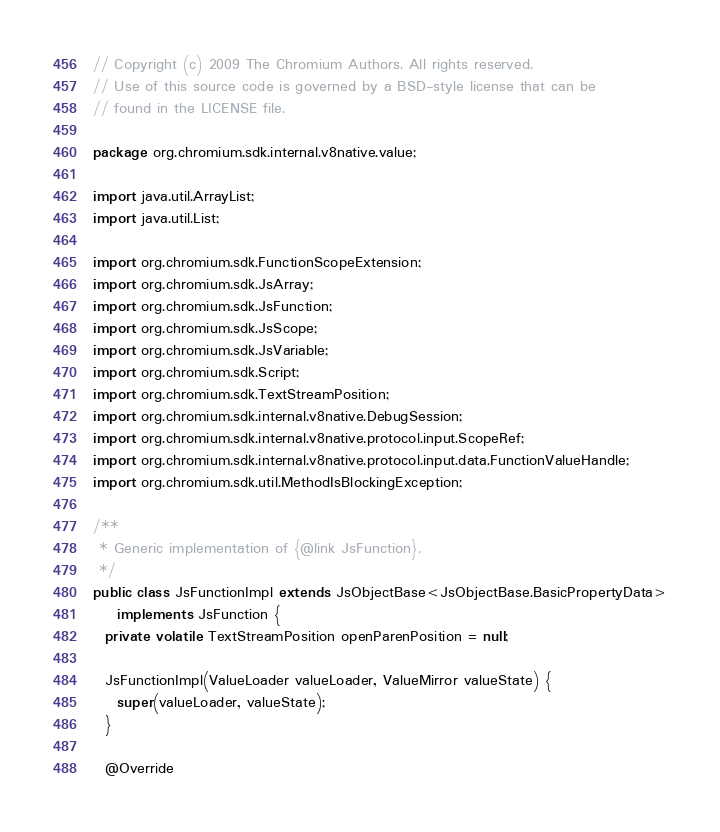Convert code to text. <code><loc_0><loc_0><loc_500><loc_500><_Java_>// Copyright (c) 2009 The Chromium Authors. All rights reserved.
// Use of this source code is governed by a BSD-style license that can be
// found in the LICENSE file.

package org.chromium.sdk.internal.v8native.value;

import java.util.ArrayList;
import java.util.List;

import org.chromium.sdk.FunctionScopeExtension;
import org.chromium.sdk.JsArray;
import org.chromium.sdk.JsFunction;
import org.chromium.sdk.JsScope;
import org.chromium.sdk.JsVariable;
import org.chromium.sdk.Script;
import org.chromium.sdk.TextStreamPosition;
import org.chromium.sdk.internal.v8native.DebugSession;
import org.chromium.sdk.internal.v8native.protocol.input.ScopeRef;
import org.chromium.sdk.internal.v8native.protocol.input.data.FunctionValueHandle;
import org.chromium.sdk.util.MethodIsBlockingException;

/**
 * Generic implementation of {@link JsFunction}.
 */
public class JsFunctionImpl extends JsObjectBase<JsObjectBase.BasicPropertyData>
    implements JsFunction {
  private volatile TextStreamPosition openParenPosition = null;

  JsFunctionImpl(ValueLoader valueLoader, ValueMirror valueState) {
    super(valueLoader, valueState);
  }

  @Override</code> 